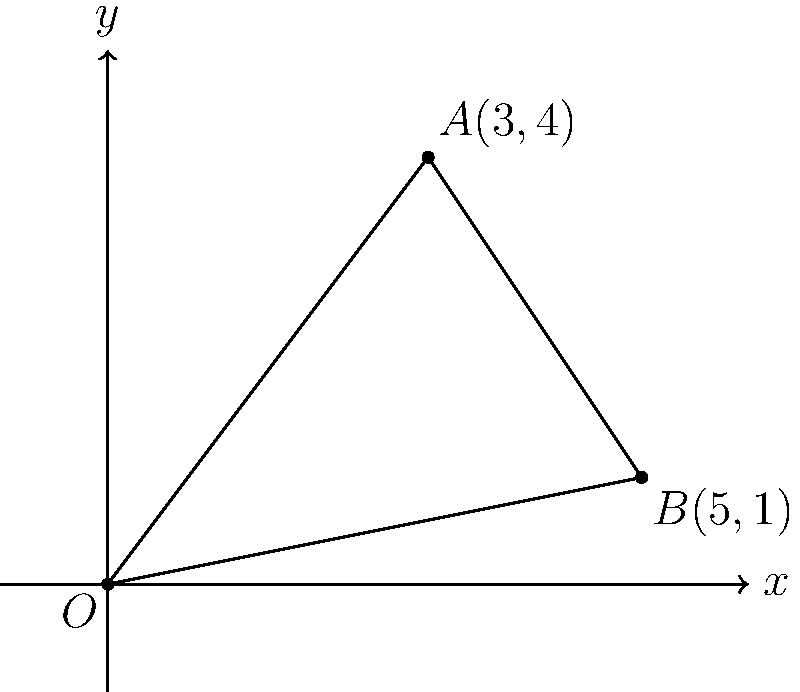In your town's layout, two streets intersect at the origin O(0,0) on a coordinate grid. One street runs through point A(3,4), while the other passes through point B(5,1). As a local reporter covering urban planning, you need to determine the angle between these two streets for your story. What is the measure of this angle in degrees, rounded to the nearest whole number? To find the angle between the two streets, we'll follow these steps:

1) First, we need to find the vectors representing each street:
   Vector OA: $\vec{OA} = (3-0, 4-0) = (3, 4)$
   Vector OB: $\vec{OB} = (5-0, 1-0) = (5, 1)$

2) The angle between two vectors can be found using the dot product formula:
   $\cos \theta = \frac{\vec{OA} \cdot \vec{OB}}{|\vec{OA}| |\vec{OB}|}$

3) Calculate the dot product $\vec{OA} \cdot \vec{OB}$:
   $\vec{OA} \cdot \vec{OB} = 3(5) + 4(1) = 15 + 4 = 19$

4) Calculate the magnitudes of the vectors:
   $|\vec{OA}| = \sqrt{3^2 + 4^2} = \sqrt{25} = 5$
   $|\vec{OB}| = \sqrt{5^2 + 1^2} = \sqrt{26}$

5) Substitute into the formula:
   $\cos \theta = \frac{19}{5\sqrt{26}}$

6) Take the inverse cosine (arccos) of both sides:
   $\theta = \arccos(\frac{19}{5\sqrt{26}})$

7) Calculate and convert to degrees:
   $\theta \approx 0.6435 \text{ radians} \approx 36.87°$

8) Rounding to the nearest whole number:
   $\theta \approx 37°$
Answer: 37° 